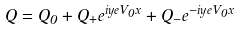Convert formula to latex. <formula><loc_0><loc_0><loc_500><loc_500>Q = Q _ { 0 } + Q _ { + } e ^ { i y e V _ { 0 } x } + Q _ { - } e ^ { - i y e V _ { 0 } x }</formula> 